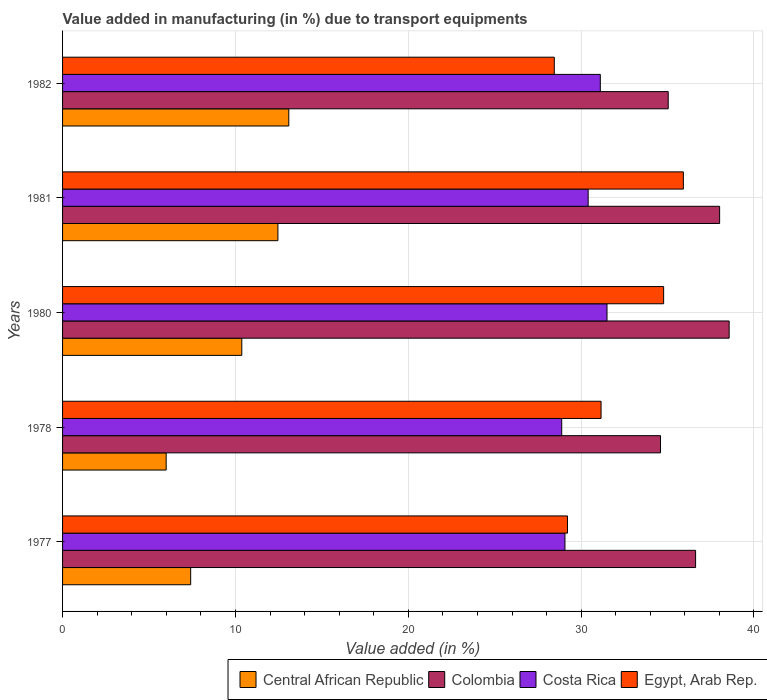What is the label of the 1st group of bars from the top?
Provide a succinct answer. 1982. What is the percentage of value added in manufacturing due to transport equipments in Costa Rica in 1980?
Make the answer very short. 31.5. Across all years, what is the maximum percentage of value added in manufacturing due to transport equipments in Egypt, Arab Rep.?
Offer a very short reply. 35.91. Across all years, what is the minimum percentage of value added in manufacturing due to transport equipments in Central African Republic?
Your response must be concise. 5.99. In which year was the percentage of value added in manufacturing due to transport equipments in Colombia maximum?
Offer a terse response. 1980. What is the total percentage of value added in manufacturing due to transport equipments in Central African Republic in the graph?
Make the answer very short. 49.32. What is the difference between the percentage of value added in manufacturing due to transport equipments in Egypt, Arab Rep. in 1977 and that in 1978?
Keep it short and to the point. -1.94. What is the difference between the percentage of value added in manufacturing due to transport equipments in Central African Republic in 1980 and the percentage of value added in manufacturing due to transport equipments in Costa Rica in 1982?
Provide a short and direct response. -20.74. What is the average percentage of value added in manufacturing due to transport equipments in Colombia per year?
Make the answer very short. 36.57. In the year 1982, what is the difference between the percentage of value added in manufacturing due to transport equipments in Central African Republic and percentage of value added in manufacturing due to transport equipments in Costa Rica?
Ensure brevity in your answer.  -18.02. What is the ratio of the percentage of value added in manufacturing due to transport equipments in Colombia in 1977 to that in 1980?
Offer a terse response. 0.95. Is the percentage of value added in manufacturing due to transport equipments in Central African Republic in 1978 less than that in 1981?
Offer a very short reply. Yes. What is the difference between the highest and the second highest percentage of value added in manufacturing due to transport equipments in Egypt, Arab Rep.?
Provide a succinct answer. 1.14. What is the difference between the highest and the lowest percentage of value added in manufacturing due to transport equipments in Colombia?
Make the answer very short. 3.97. Is the sum of the percentage of value added in manufacturing due to transport equipments in Colombia in 1980 and 1981 greater than the maximum percentage of value added in manufacturing due to transport equipments in Egypt, Arab Rep. across all years?
Ensure brevity in your answer.  Yes. Is it the case that in every year, the sum of the percentage of value added in manufacturing due to transport equipments in Central African Republic and percentage of value added in manufacturing due to transport equipments in Colombia is greater than the sum of percentage of value added in manufacturing due to transport equipments in Egypt, Arab Rep. and percentage of value added in manufacturing due to transport equipments in Costa Rica?
Provide a succinct answer. No. What does the 1st bar from the top in 1978 represents?
Offer a very short reply. Egypt, Arab Rep. What does the 4th bar from the bottom in 1982 represents?
Keep it short and to the point. Egypt, Arab Rep. Is it the case that in every year, the sum of the percentage of value added in manufacturing due to transport equipments in Central African Republic and percentage of value added in manufacturing due to transport equipments in Colombia is greater than the percentage of value added in manufacturing due to transport equipments in Costa Rica?
Your answer should be compact. Yes. How many bars are there?
Offer a very short reply. 20. Does the graph contain grids?
Offer a terse response. Yes. Where does the legend appear in the graph?
Give a very brief answer. Bottom right. How are the legend labels stacked?
Your response must be concise. Horizontal. What is the title of the graph?
Ensure brevity in your answer.  Value added in manufacturing (in %) due to transport equipments. What is the label or title of the X-axis?
Give a very brief answer. Value added (in %). What is the Value added (in %) of Central African Republic in 1977?
Ensure brevity in your answer.  7.41. What is the Value added (in %) of Colombia in 1977?
Your answer should be compact. 36.62. What is the Value added (in %) in Costa Rica in 1977?
Offer a very short reply. 29.06. What is the Value added (in %) of Egypt, Arab Rep. in 1977?
Your answer should be compact. 29.21. What is the Value added (in %) of Central African Republic in 1978?
Offer a terse response. 5.99. What is the Value added (in %) in Colombia in 1978?
Your answer should be very brief. 34.59. What is the Value added (in %) in Costa Rica in 1978?
Provide a short and direct response. 28.88. What is the Value added (in %) in Egypt, Arab Rep. in 1978?
Your answer should be very brief. 31.15. What is the Value added (in %) of Central African Republic in 1980?
Offer a terse response. 10.37. What is the Value added (in %) in Colombia in 1980?
Give a very brief answer. 38.56. What is the Value added (in %) in Costa Rica in 1980?
Your answer should be compact. 31.5. What is the Value added (in %) of Egypt, Arab Rep. in 1980?
Your answer should be very brief. 34.77. What is the Value added (in %) of Central African Republic in 1981?
Ensure brevity in your answer.  12.46. What is the Value added (in %) of Colombia in 1981?
Keep it short and to the point. 38.01. What is the Value added (in %) of Costa Rica in 1981?
Ensure brevity in your answer.  30.41. What is the Value added (in %) of Egypt, Arab Rep. in 1981?
Your response must be concise. 35.91. What is the Value added (in %) in Central African Republic in 1982?
Your answer should be compact. 13.09. What is the Value added (in %) in Colombia in 1982?
Give a very brief answer. 35.04. What is the Value added (in %) in Costa Rica in 1982?
Keep it short and to the point. 31.11. What is the Value added (in %) of Egypt, Arab Rep. in 1982?
Provide a succinct answer. 28.45. Across all years, what is the maximum Value added (in %) in Central African Republic?
Provide a succinct answer. 13.09. Across all years, what is the maximum Value added (in %) in Colombia?
Offer a terse response. 38.56. Across all years, what is the maximum Value added (in %) of Costa Rica?
Offer a terse response. 31.5. Across all years, what is the maximum Value added (in %) in Egypt, Arab Rep.?
Offer a very short reply. 35.91. Across all years, what is the minimum Value added (in %) of Central African Republic?
Give a very brief answer. 5.99. Across all years, what is the minimum Value added (in %) of Colombia?
Give a very brief answer. 34.59. Across all years, what is the minimum Value added (in %) in Costa Rica?
Provide a short and direct response. 28.88. Across all years, what is the minimum Value added (in %) of Egypt, Arab Rep.?
Your answer should be very brief. 28.45. What is the total Value added (in %) in Central African Republic in the graph?
Keep it short and to the point. 49.32. What is the total Value added (in %) of Colombia in the graph?
Offer a very short reply. 182.83. What is the total Value added (in %) in Costa Rica in the graph?
Offer a terse response. 150.95. What is the total Value added (in %) in Egypt, Arab Rep. in the graph?
Provide a succinct answer. 159.5. What is the difference between the Value added (in %) in Central African Republic in 1977 and that in 1978?
Offer a very short reply. 1.42. What is the difference between the Value added (in %) in Colombia in 1977 and that in 1978?
Your answer should be compact. 2.03. What is the difference between the Value added (in %) in Costa Rica in 1977 and that in 1978?
Your answer should be very brief. 0.19. What is the difference between the Value added (in %) of Egypt, Arab Rep. in 1977 and that in 1978?
Make the answer very short. -1.94. What is the difference between the Value added (in %) of Central African Republic in 1977 and that in 1980?
Make the answer very short. -2.96. What is the difference between the Value added (in %) in Colombia in 1977 and that in 1980?
Your response must be concise. -1.94. What is the difference between the Value added (in %) of Costa Rica in 1977 and that in 1980?
Your answer should be compact. -2.43. What is the difference between the Value added (in %) in Egypt, Arab Rep. in 1977 and that in 1980?
Make the answer very short. -5.56. What is the difference between the Value added (in %) of Central African Republic in 1977 and that in 1981?
Provide a succinct answer. -5.05. What is the difference between the Value added (in %) of Colombia in 1977 and that in 1981?
Make the answer very short. -1.39. What is the difference between the Value added (in %) in Costa Rica in 1977 and that in 1981?
Provide a short and direct response. -1.34. What is the difference between the Value added (in %) of Egypt, Arab Rep. in 1977 and that in 1981?
Give a very brief answer. -6.7. What is the difference between the Value added (in %) in Central African Republic in 1977 and that in 1982?
Give a very brief answer. -5.68. What is the difference between the Value added (in %) in Colombia in 1977 and that in 1982?
Provide a succinct answer. 1.58. What is the difference between the Value added (in %) of Costa Rica in 1977 and that in 1982?
Keep it short and to the point. -2.05. What is the difference between the Value added (in %) of Egypt, Arab Rep. in 1977 and that in 1982?
Keep it short and to the point. 0.76. What is the difference between the Value added (in %) of Central African Republic in 1978 and that in 1980?
Give a very brief answer. -4.37. What is the difference between the Value added (in %) of Colombia in 1978 and that in 1980?
Your response must be concise. -3.97. What is the difference between the Value added (in %) of Costa Rica in 1978 and that in 1980?
Make the answer very short. -2.62. What is the difference between the Value added (in %) of Egypt, Arab Rep. in 1978 and that in 1980?
Make the answer very short. -3.62. What is the difference between the Value added (in %) in Central African Republic in 1978 and that in 1981?
Keep it short and to the point. -6.46. What is the difference between the Value added (in %) of Colombia in 1978 and that in 1981?
Give a very brief answer. -3.42. What is the difference between the Value added (in %) of Costa Rica in 1978 and that in 1981?
Ensure brevity in your answer.  -1.53. What is the difference between the Value added (in %) in Egypt, Arab Rep. in 1978 and that in 1981?
Offer a terse response. -4.76. What is the difference between the Value added (in %) of Central African Republic in 1978 and that in 1982?
Offer a terse response. -7.09. What is the difference between the Value added (in %) in Colombia in 1978 and that in 1982?
Provide a succinct answer. -0.45. What is the difference between the Value added (in %) in Costa Rica in 1978 and that in 1982?
Make the answer very short. -2.23. What is the difference between the Value added (in %) in Egypt, Arab Rep. in 1978 and that in 1982?
Provide a short and direct response. 2.71. What is the difference between the Value added (in %) in Central African Republic in 1980 and that in 1981?
Give a very brief answer. -2.09. What is the difference between the Value added (in %) in Colombia in 1980 and that in 1981?
Your answer should be compact. 0.55. What is the difference between the Value added (in %) of Costa Rica in 1980 and that in 1981?
Offer a very short reply. 1.09. What is the difference between the Value added (in %) of Egypt, Arab Rep. in 1980 and that in 1981?
Give a very brief answer. -1.14. What is the difference between the Value added (in %) in Central African Republic in 1980 and that in 1982?
Your response must be concise. -2.72. What is the difference between the Value added (in %) in Colombia in 1980 and that in 1982?
Give a very brief answer. 3.53. What is the difference between the Value added (in %) in Costa Rica in 1980 and that in 1982?
Make the answer very short. 0.39. What is the difference between the Value added (in %) of Egypt, Arab Rep. in 1980 and that in 1982?
Make the answer very short. 6.33. What is the difference between the Value added (in %) in Central African Republic in 1981 and that in 1982?
Ensure brevity in your answer.  -0.63. What is the difference between the Value added (in %) of Colombia in 1981 and that in 1982?
Provide a succinct answer. 2.97. What is the difference between the Value added (in %) of Costa Rica in 1981 and that in 1982?
Give a very brief answer. -0.7. What is the difference between the Value added (in %) in Egypt, Arab Rep. in 1981 and that in 1982?
Give a very brief answer. 7.47. What is the difference between the Value added (in %) in Central African Republic in 1977 and the Value added (in %) in Colombia in 1978?
Your response must be concise. -27.18. What is the difference between the Value added (in %) of Central African Republic in 1977 and the Value added (in %) of Costa Rica in 1978?
Provide a succinct answer. -21.47. What is the difference between the Value added (in %) of Central African Republic in 1977 and the Value added (in %) of Egypt, Arab Rep. in 1978?
Ensure brevity in your answer.  -23.74. What is the difference between the Value added (in %) in Colombia in 1977 and the Value added (in %) in Costa Rica in 1978?
Your answer should be very brief. 7.75. What is the difference between the Value added (in %) of Colombia in 1977 and the Value added (in %) of Egypt, Arab Rep. in 1978?
Offer a very short reply. 5.47. What is the difference between the Value added (in %) in Costa Rica in 1977 and the Value added (in %) in Egypt, Arab Rep. in 1978?
Make the answer very short. -2.09. What is the difference between the Value added (in %) in Central African Republic in 1977 and the Value added (in %) in Colombia in 1980?
Provide a succinct answer. -31.15. What is the difference between the Value added (in %) in Central African Republic in 1977 and the Value added (in %) in Costa Rica in 1980?
Ensure brevity in your answer.  -24.09. What is the difference between the Value added (in %) in Central African Republic in 1977 and the Value added (in %) in Egypt, Arab Rep. in 1980?
Your response must be concise. -27.36. What is the difference between the Value added (in %) in Colombia in 1977 and the Value added (in %) in Costa Rica in 1980?
Give a very brief answer. 5.13. What is the difference between the Value added (in %) in Colombia in 1977 and the Value added (in %) in Egypt, Arab Rep. in 1980?
Provide a succinct answer. 1.85. What is the difference between the Value added (in %) of Costa Rica in 1977 and the Value added (in %) of Egypt, Arab Rep. in 1980?
Offer a very short reply. -5.71. What is the difference between the Value added (in %) in Central African Republic in 1977 and the Value added (in %) in Colombia in 1981?
Keep it short and to the point. -30.6. What is the difference between the Value added (in %) in Central African Republic in 1977 and the Value added (in %) in Costa Rica in 1981?
Ensure brevity in your answer.  -23. What is the difference between the Value added (in %) in Central African Republic in 1977 and the Value added (in %) in Egypt, Arab Rep. in 1981?
Make the answer very short. -28.5. What is the difference between the Value added (in %) in Colombia in 1977 and the Value added (in %) in Costa Rica in 1981?
Ensure brevity in your answer.  6.22. What is the difference between the Value added (in %) of Colombia in 1977 and the Value added (in %) of Egypt, Arab Rep. in 1981?
Your answer should be very brief. 0.71. What is the difference between the Value added (in %) in Costa Rica in 1977 and the Value added (in %) in Egypt, Arab Rep. in 1981?
Your response must be concise. -6.85. What is the difference between the Value added (in %) in Central African Republic in 1977 and the Value added (in %) in Colombia in 1982?
Keep it short and to the point. -27.63. What is the difference between the Value added (in %) of Central African Republic in 1977 and the Value added (in %) of Costa Rica in 1982?
Keep it short and to the point. -23.7. What is the difference between the Value added (in %) of Central African Republic in 1977 and the Value added (in %) of Egypt, Arab Rep. in 1982?
Offer a terse response. -21.04. What is the difference between the Value added (in %) in Colombia in 1977 and the Value added (in %) in Costa Rica in 1982?
Your answer should be compact. 5.51. What is the difference between the Value added (in %) in Colombia in 1977 and the Value added (in %) in Egypt, Arab Rep. in 1982?
Provide a short and direct response. 8.18. What is the difference between the Value added (in %) in Costa Rica in 1977 and the Value added (in %) in Egypt, Arab Rep. in 1982?
Offer a terse response. 0.62. What is the difference between the Value added (in %) of Central African Republic in 1978 and the Value added (in %) of Colombia in 1980?
Give a very brief answer. -32.57. What is the difference between the Value added (in %) in Central African Republic in 1978 and the Value added (in %) in Costa Rica in 1980?
Your response must be concise. -25.5. What is the difference between the Value added (in %) in Central African Republic in 1978 and the Value added (in %) in Egypt, Arab Rep. in 1980?
Your response must be concise. -28.78. What is the difference between the Value added (in %) in Colombia in 1978 and the Value added (in %) in Costa Rica in 1980?
Keep it short and to the point. 3.09. What is the difference between the Value added (in %) in Colombia in 1978 and the Value added (in %) in Egypt, Arab Rep. in 1980?
Make the answer very short. -0.18. What is the difference between the Value added (in %) in Costa Rica in 1978 and the Value added (in %) in Egypt, Arab Rep. in 1980?
Offer a very short reply. -5.9. What is the difference between the Value added (in %) in Central African Republic in 1978 and the Value added (in %) in Colombia in 1981?
Ensure brevity in your answer.  -32.02. What is the difference between the Value added (in %) of Central African Republic in 1978 and the Value added (in %) of Costa Rica in 1981?
Provide a succinct answer. -24.41. What is the difference between the Value added (in %) of Central African Republic in 1978 and the Value added (in %) of Egypt, Arab Rep. in 1981?
Offer a very short reply. -29.92. What is the difference between the Value added (in %) in Colombia in 1978 and the Value added (in %) in Costa Rica in 1981?
Provide a succinct answer. 4.18. What is the difference between the Value added (in %) in Colombia in 1978 and the Value added (in %) in Egypt, Arab Rep. in 1981?
Your answer should be compact. -1.32. What is the difference between the Value added (in %) of Costa Rica in 1978 and the Value added (in %) of Egypt, Arab Rep. in 1981?
Your response must be concise. -7.04. What is the difference between the Value added (in %) in Central African Republic in 1978 and the Value added (in %) in Colombia in 1982?
Your answer should be compact. -29.04. What is the difference between the Value added (in %) of Central African Republic in 1978 and the Value added (in %) of Costa Rica in 1982?
Ensure brevity in your answer.  -25.12. What is the difference between the Value added (in %) of Central African Republic in 1978 and the Value added (in %) of Egypt, Arab Rep. in 1982?
Offer a very short reply. -22.45. What is the difference between the Value added (in %) in Colombia in 1978 and the Value added (in %) in Costa Rica in 1982?
Give a very brief answer. 3.48. What is the difference between the Value added (in %) in Colombia in 1978 and the Value added (in %) in Egypt, Arab Rep. in 1982?
Your answer should be compact. 6.14. What is the difference between the Value added (in %) of Costa Rica in 1978 and the Value added (in %) of Egypt, Arab Rep. in 1982?
Your answer should be very brief. 0.43. What is the difference between the Value added (in %) in Central African Republic in 1980 and the Value added (in %) in Colombia in 1981?
Ensure brevity in your answer.  -27.64. What is the difference between the Value added (in %) of Central African Republic in 1980 and the Value added (in %) of Costa Rica in 1981?
Provide a succinct answer. -20.04. What is the difference between the Value added (in %) in Central African Republic in 1980 and the Value added (in %) in Egypt, Arab Rep. in 1981?
Provide a succinct answer. -25.55. What is the difference between the Value added (in %) in Colombia in 1980 and the Value added (in %) in Costa Rica in 1981?
Keep it short and to the point. 8.16. What is the difference between the Value added (in %) in Colombia in 1980 and the Value added (in %) in Egypt, Arab Rep. in 1981?
Give a very brief answer. 2.65. What is the difference between the Value added (in %) of Costa Rica in 1980 and the Value added (in %) of Egypt, Arab Rep. in 1981?
Your answer should be compact. -4.42. What is the difference between the Value added (in %) of Central African Republic in 1980 and the Value added (in %) of Colombia in 1982?
Provide a short and direct response. -24.67. What is the difference between the Value added (in %) of Central African Republic in 1980 and the Value added (in %) of Costa Rica in 1982?
Make the answer very short. -20.74. What is the difference between the Value added (in %) of Central African Republic in 1980 and the Value added (in %) of Egypt, Arab Rep. in 1982?
Provide a short and direct response. -18.08. What is the difference between the Value added (in %) of Colombia in 1980 and the Value added (in %) of Costa Rica in 1982?
Provide a succinct answer. 7.45. What is the difference between the Value added (in %) of Colombia in 1980 and the Value added (in %) of Egypt, Arab Rep. in 1982?
Your response must be concise. 10.12. What is the difference between the Value added (in %) of Costa Rica in 1980 and the Value added (in %) of Egypt, Arab Rep. in 1982?
Offer a very short reply. 3.05. What is the difference between the Value added (in %) of Central African Republic in 1981 and the Value added (in %) of Colombia in 1982?
Offer a terse response. -22.58. What is the difference between the Value added (in %) of Central African Republic in 1981 and the Value added (in %) of Costa Rica in 1982?
Provide a short and direct response. -18.65. What is the difference between the Value added (in %) of Central African Republic in 1981 and the Value added (in %) of Egypt, Arab Rep. in 1982?
Ensure brevity in your answer.  -15.99. What is the difference between the Value added (in %) of Colombia in 1981 and the Value added (in %) of Costa Rica in 1982?
Your response must be concise. 6.9. What is the difference between the Value added (in %) of Colombia in 1981 and the Value added (in %) of Egypt, Arab Rep. in 1982?
Ensure brevity in your answer.  9.56. What is the difference between the Value added (in %) in Costa Rica in 1981 and the Value added (in %) in Egypt, Arab Rep. in 1982?
Make the answer very short. 1.96. What is the average Value added (in %) of Central African Republic per year?
Your response must be concise. 9.86. What is the average Value added (in %) in Colombia per year?
Ensure brevity in your answer.  36.57. What is the average Value added (in %) in Costa Rica per year?
Keep it short and to the point. 30.19. What is the average Value added (in %) of Egypt, Arab Rep. per year?
Your answer should be compact. 31.9. In the year 1977, what is the difference between the Value added (in %) of Central African Republic and Value added (in %) of Colombia?
Make the answer very short. -29.21. In the year 1977, what is the difference between the Value added (in %) of Central African Republic and Value added (in %) of Costa Rica?
Offer a terse response. -21.65. In the year 1977, what is the difference between the Value added (in %) of Central African Republic and Value added (in %) of Egypt, Arab Rep.?
Offer a very short reply. -21.8. In the year 1977, what is the difference between the Value added (in %) in Colombia and Value added (in %) in Costa Rica?
Give a very brief answer. 7.56. In the year 1977, what is the difference between the Value added (in %) of Colombia and Value added (in %) of Egypt, Arab Rep.?
Provide a short and direct response. 7.41. In the year 1977, what is the difference between the Value added (in %) of Costa Rica and Value added (in %) of Egypt, Arab Rep.?
Keep it short and to the point. -0.15. In the year 1978, what is the difference between the Value added (in %) of Central African Republic and Value added (in %) of Colombia?
Provide a succinct answer. -28.6. In the year 1978, what is the difference between the Value added (in %) in Central African Republic and Value added (in %) in Costa Rica?
Ensure brevity in your answer.  -22.88. In the year 1978, what is the difference between the Value added (in %) in Central African Republic and Value added (in %) in Egypt, Arab Rep.?
Offer a terse response. -25.16. In the year 1978, what is the difference between the Value added (in %) of Colombia and Value added (in %) of Costa Rica?
Make the answer very short. 5.71. In the year 1978, what is the difference between the Value added (in %) of Colombia and Value added (in %) of Egypt, Arab Rep.?
Make the answer very short. 3.44. In the year 1978, what is the difference between the Value added (in %) of Costa Rica and Value added (in %) of Egypt, Arab Rep.?
Your answer should be very brief. -2.28. In the year 1980, what is the difference between the Value added (in %) in Central African Republic and Value added (in %) in Colombia?
Your response must be concise. -28.2. In the year 1980, what is the difference between the Value added (in %) of Central African Republic and Value added (in %) of Costa Rica?
Your answer should be compact. -21.13. In the year 1980, what is the difference between the Value added (in %) of Central African Republic and Value added (in %) of Egypt, Arab Rep.?
Your response must be concise. -24.4. In the year 1980, what is the difference between the Value added (in %) of Colombia and Value added (in %) of Costa Rica?
Your response must be concise. 7.07. In the year 1980, what is the difference between the Value added (in %) of Colombia and Value added (in %) of Egypt, Arab Rep.?
Your response must be concise. 3.79. In the year 1980, what is the difference between the Value added (in %) of Costa Rica and Value added (in %) of Egypt, Arab Rep.?
Your answer should be compact. -3.28. In the year 1981, what is the difference between the Value added (in %) of Central African Republic and Value added (in %) of Colombia?
Keep it short and to the point. -25.55. In the year 1981, what is the difference between the Value added (in %) in Central African Republic and Value added (in %) in Costa Rica?
Offer a terse response. -17.95. In the year 1981, what is the difference between the Value added (in %) in Central African Republic and Value added (in %) in Egypt, Arab Rep.?
Your answer should be very brief. -23.46. In the year 1981, what is the difference between the Value added (in %) of Colombia and Value added (in %) of Costa Rica?
Provide a short and direct response. 7.61. In the year 1981, what is the difference between the Value added (in %) in Colombia and Value added (in %) in Egypt, Arab Rep.?
Your answer should be very brief. 2.1. In the year 1981, what is the difference between the Value added (in %) in Costa Rica and Value added (in %) in Egypt, Arab Rep.?
Offer a terse response. -5.51. In the year 1982, what is the difference between the Value added (in %) in Central African Republic and Value added (in %) in Colombia?
Your answer should be compact. -21.95. In the year 1982, what is the difference between the Value added (in %) in Central African Republic and Value added (in %) in Costa Rica?
Ensure brevity in your answer.  -18.02. In the year 1982, what is the difference between the Value added (in %) of Central African Republic and Value added (in %) of Egypt, Arab Rep.?
Give a very brief answer. -15.36. In the year 1982, what is the difference between the Value added (in %) in Colombia and Value added (in %) in Costa Rica?
Keep it short and to the point. 3.93. In the year 1982, what is the difference between the Value added (in %) in Colombia and Value added (in %) in Egypt, Arab Rep.?
Keep it short and to the point. 6.59. In the year 1982, what is the difference between the Value added (in %) of Costa Rica and Value added (in %) of Egypt, Arab Rep.?
Your answer should be compact. 2.66. What is the ratio of the Value added (in %) in Central African Republic in 1977 to that in 1978?
Give a very brief answer. 1.24. What is the ratio of the Value added (in %) in Colombia in 1977 to that in 1978?
Your answer should be very brief. 1.06. What is the ratio of the Value added (in %) in Egypt, Arab Rep. in 1977 to that in 1978?
Ensure brevity in your answer.  0.94. What is the ratio of the Value added (in %) in Central African Republic in 1977 to that in 1980?
Offer a terse response. 0.71. What is the ratio of the Value added (in %) in Colombia in 1977 to that in 1980?
Your response must be concise. 0.95. What is the ratio of the Value added (in %) of Costa Rica in 1977 to that in 1980?
Give a very brief answer. 0.92. What is the ratio of the Value added (in %) of Egypt, Arab Rep. in 1977 to that in 1980?
Make the answer very short. 0.84. What is the ratio of the Value added (in %) in Central African Republic in 1977 to that in 1981?
Your answer should be compact. 0.59. What is the ratio of the Value added (in %) in Colombia in 1977 to that in 1981?
Your response must be concise. 0.96. What is the ratio of the Value added (in %) in Costa Rica in 1977 to that in 1981?
Your answer should be very brief. 0.96. What is the ratio of the Value added (in %) of Egypt, Arab Rep. in 1977 to that in 1981?
Keep it short and to the point. 0.81. What is the ratio of the Value added (in %) in Central African Republic in 1977 to that in 1982?
Your answer should be compact. 0.57. What is the ratio of the Value added (in %) in Colombia in 1977 to that in 1982?
Your response must be concise. 1.05. What is the ratio of the Value added (in %) in Costa Rica in 1977 to that in 1982?
Offer a very short reply. 0.93. What is the ratio of the Value added (in %) of Egypt, Arab Rep. in 1977 to that in 1982?
Offer a terse response. 1.03. What is the ratio of the Value added (in %) of Central African Republic in 1978 to that in 1980?
Your response must be concise. 0.58. What is the ratio of the Value added (in %) of Colombia in 1978 to that in 1980?
Your answer should be very brief. 0.9. What is the ratio of the Value added (in %) in Costa Rica in 1978 to that in 1980?
Make the answer very short. 0.92. What is the ratio of the Value added (in %) of Egypt, Arab Rep. in 1978 to that in 1980?
Provide a succinct answer. 0.9. What is the ratio of the Value added (in %) in Central African Republic in 1978 to that in 1981?
Your response must be concise. 0.48. What is the ratio of the Value added (in %) of Colombia in 1978 to that in 1981?
Offer a terse response. 0.91. What is the ratio of the Value added (in %) in Costa Rica in 1978 to that in 1981?
Offer a terse response. 0.95. What is the ratio of the Value added (in %) in Egypt, Arab Rep. in 1978 to that in 1981?
Your answer should be compact. 0.87. What is the ratio of the Value added (in %) of Central African Republic in 1978 to that in 1982?
Make the answer very short. 0.46. What is the ratio of the Value added (in %) in Colombia in 1978 to that in 1982?
Provide a short and direct response. 0.99. What is the ratio of the Value added (in %) in Costa Rica in 1978 to that in 1982?
Make the answer very short. 0.93. What is the ratio of the Value added (in %) of Egypt, Arab Rep. in 1978 to that in 1982?
Your answer should be compact. 1.1. What is the ratio of the Value added (in %) in Central African Republic in 1980 to that in 1981?
Provide a short and direct response. 0.83. What is the ratio of the Value added (in %) of Colombia in 1980 to that in 1981?
Make the answer very short. 1.01. What is the ratio of the Value added (in %) in Costa Rica in 1980 to that in 1981?
Your answer should be compact. 1.04. What is the ratio of the Value added (in %) of Egypt, Arab Rep. in 1980 to that in 1981?
Your answer should be compact. 0.97. What is the ratio of the Value added (in %) in Central African Republic in 1980 to that in 1982?
Give a very brief answer. 0.79. What is the ratio of the Value added (in %) of Colombia in 1980 to that in 1982?
Provide a succinct answer. 1.1. What is the ratio of the Value added (in %) in Costa Rica in 1980 to that in 1982?
Offer a very short reply. 1.01. What is the ratio of the Value added (in %) in Egypt, Arab Rep. in 1980 to that in 1982?
Ensure brevity in your answer.  1.22. What is the ratio of the Value added (in %) in Central African Republic in 1981 to that in 1982?
Make the answer very short. 0.95. What is the ratio of the Value added (in %) of Colombia in 1981 to that in 1982?
Provide a succinct answer. 1.08. What is the ratio of the Value added (in %) of Costa Rica in 1981 to that in 1982?
Your answer should be compact. 0.98. What is the ratio of the Value added (in %) in Egypt, Arab Rep. in 1981 to that in 1982?
Ensure brevity in your answer.  1.26. What is the difference between the highest and the second highest Value added (in %) in Central African Republic?
Offer a very short reply. 0.63. What is the difference between the highest and the second highest Value added (in %) of Colombia?
Keep it short and to the point. 0.55. What is the difference between the highest and the second highest Value added (in %) of Costa Rica?
Offer a very short reply. 0.39. What is the difference between the highest and the second highest Value added (in %) of Egypt, Arab Rep.?
Offer a terse response. 1.14. What is the difference between the highest and the lowest Value added (in %) of Central African Republic?
Provide a succinct answer. 7.09. What is the difference between the highest and the lowest Value added (in %) of Colombia?
Offer a terse response. 3.97. What is the difference between the highest and the lowest Value added (in %) of Costa Rica?
Your answer should be compact. 2.62. What is the difference between the highest and the lowest Value added (in %) of Egypt, Arab Rep.?
Your answer should be very brief. 7.47. 